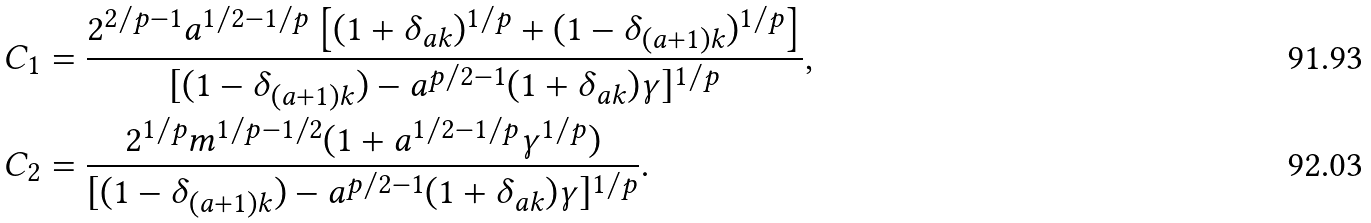<formula> <loc_0><loc_0><loc_500><loc_500>C _ { 1 } & = \frac { 2 ^ { 2 / p - 1 } a ^ { 1 / 2 - 1 / p } \left [ ( 1 + \delta _ { a k } ) ^ { 1 / p } + ( 1 - \delta _ { ( a + 1 ) k } ) ^ { 1 / p } \right ] } { [ ( 1 - \delta _ { ( a + 1 ) k } ) - a ^ { p / 2 - 1 } ( 1 + \delta _ { a k } ) \gamma ] ^ { 1 / p } } , \\ C _ { 2 } & = \frac { 2 ^ { 1 / p } m ^ { 1 / p - 1 / 2 } ( 1 + a ^ { 1 / 2 - 1 / p } \gamma ^ { 1 / p } ) } { [ ( 1 - \delta _ { ( a + 1 ) k } ) - a ^ { p / 2 - 1 } ( 1 + \delta _ { a k } ) \gamma ] ^ { 1 / p } } .</formula> 